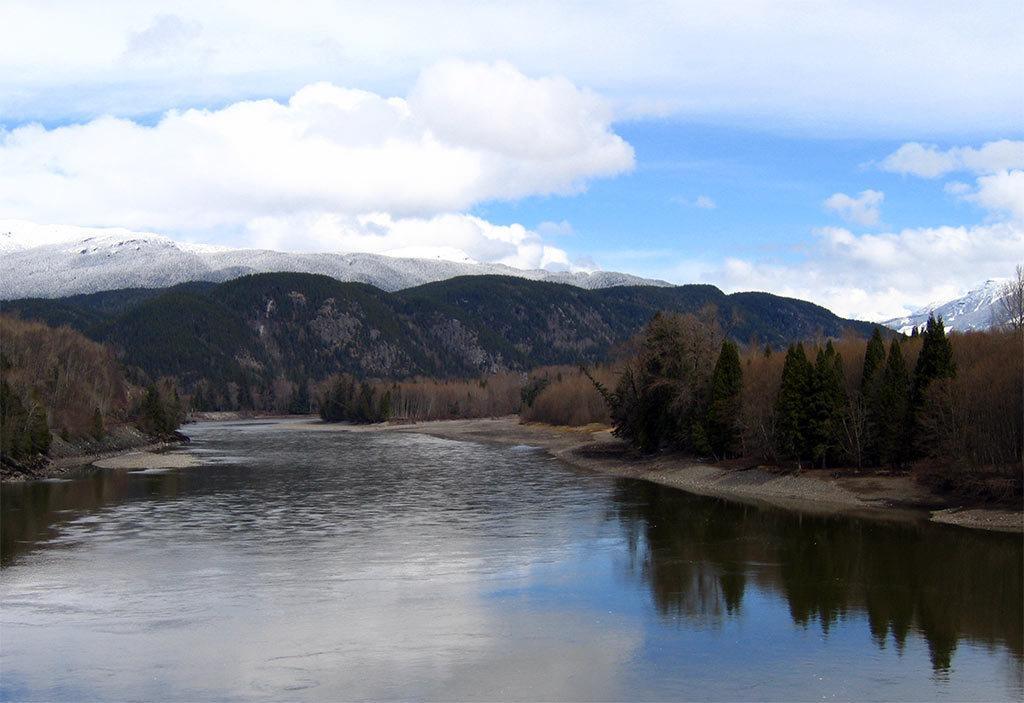Describe this image in one or two sentences. In this image, we can see some water. We can see the ground. We can see some trees and dried plants. There are a few hills covered with snow. We can also see the sky with clouds. 